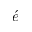Convert formula to latex. <formula><loc_0><loc_0><loc_500><loc_500>\acute { e }</formula> 